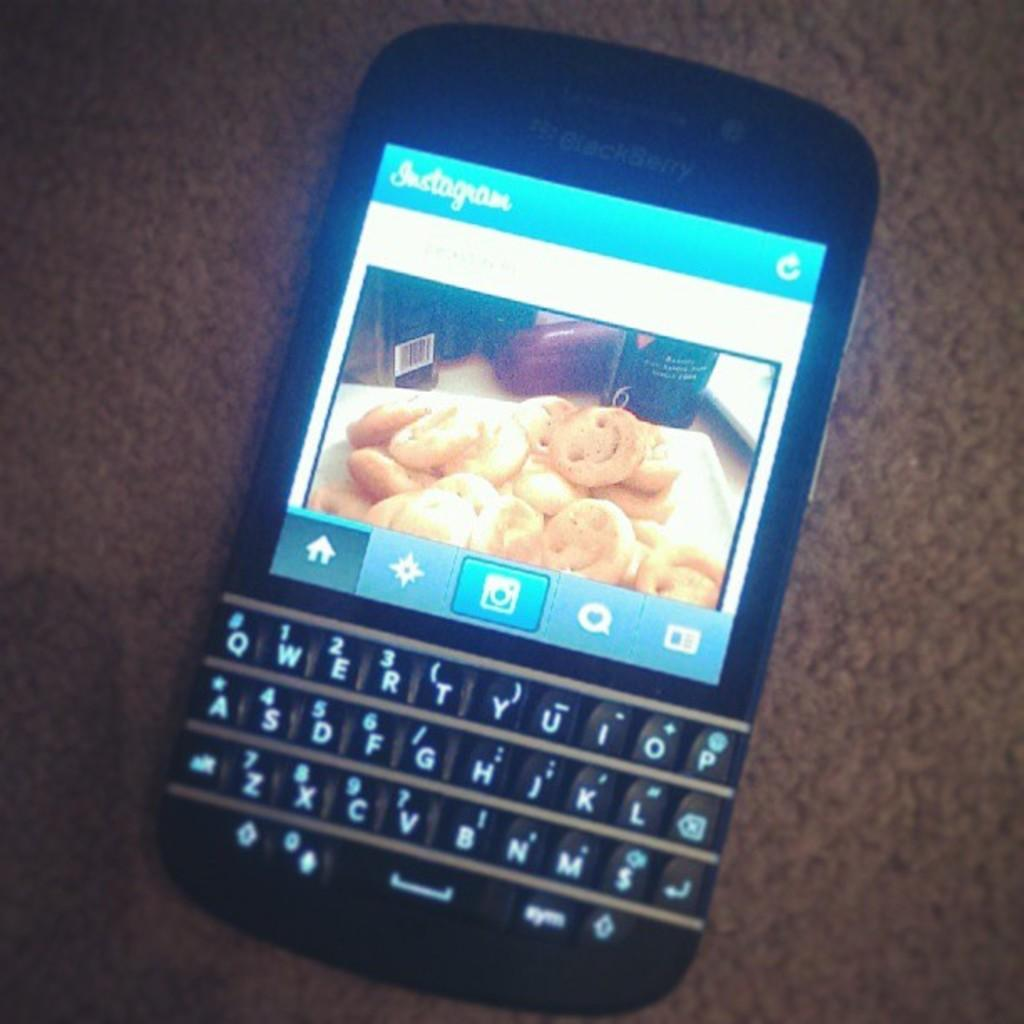<image>
Create a compact narrative representing the image presented. a BlackBerry cell phone with a picture of cookies 